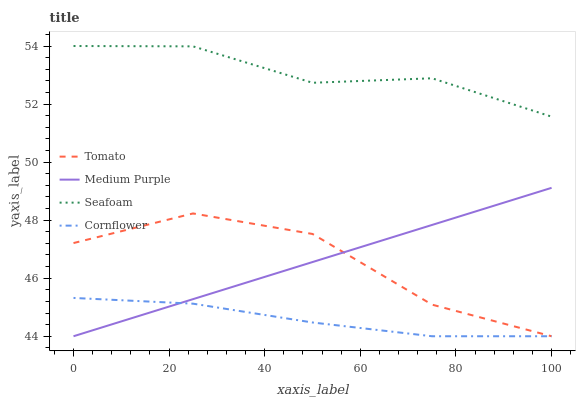Does Cornflower have the minimum area under the curve?
Answer yes or no. Yes. Does Seafoam have the maximum area under the curve?
Answer yes or no. Yes. Does Medium Purple have the minimum area under the curve?
Answer yes or no. No. Does Medium Purple have the maximum area under the curve?
Answer yes or no. No. Is Medium Purple the smoothest?
Answer yes or no. Yes. Is Tomato the roughest?
Answer yes or no. Yes. Is Seafoam the smoothest?
Answer yes or no. No. Is Seafoam the roughest?
Answer yes or no. No. Does Tomato have the lowest value?
Answer yes or no. Yes. Does Seafoam have the lowest value?
Answer yes or no. No. Does Seafoam have the highest value?
Answer yes or no. Yes. Does Medium Purple have the highest value?
Answer yes or no. No. Is Tomato less than Seafoam?
Answer yes or no. Yes. Is Seafoam greater than Cornflower?
Answer yes or no. Yes. Does Cornflower intersect Tomato?
Answer yes or no. Yes. Is Cornflower less than Tomato?
Answer yes or no. No. Is Cornflower greater than Tomato?
Answer yes or no. No. Does Tomato intersect Seafoam?
Answer yes or no. No. 